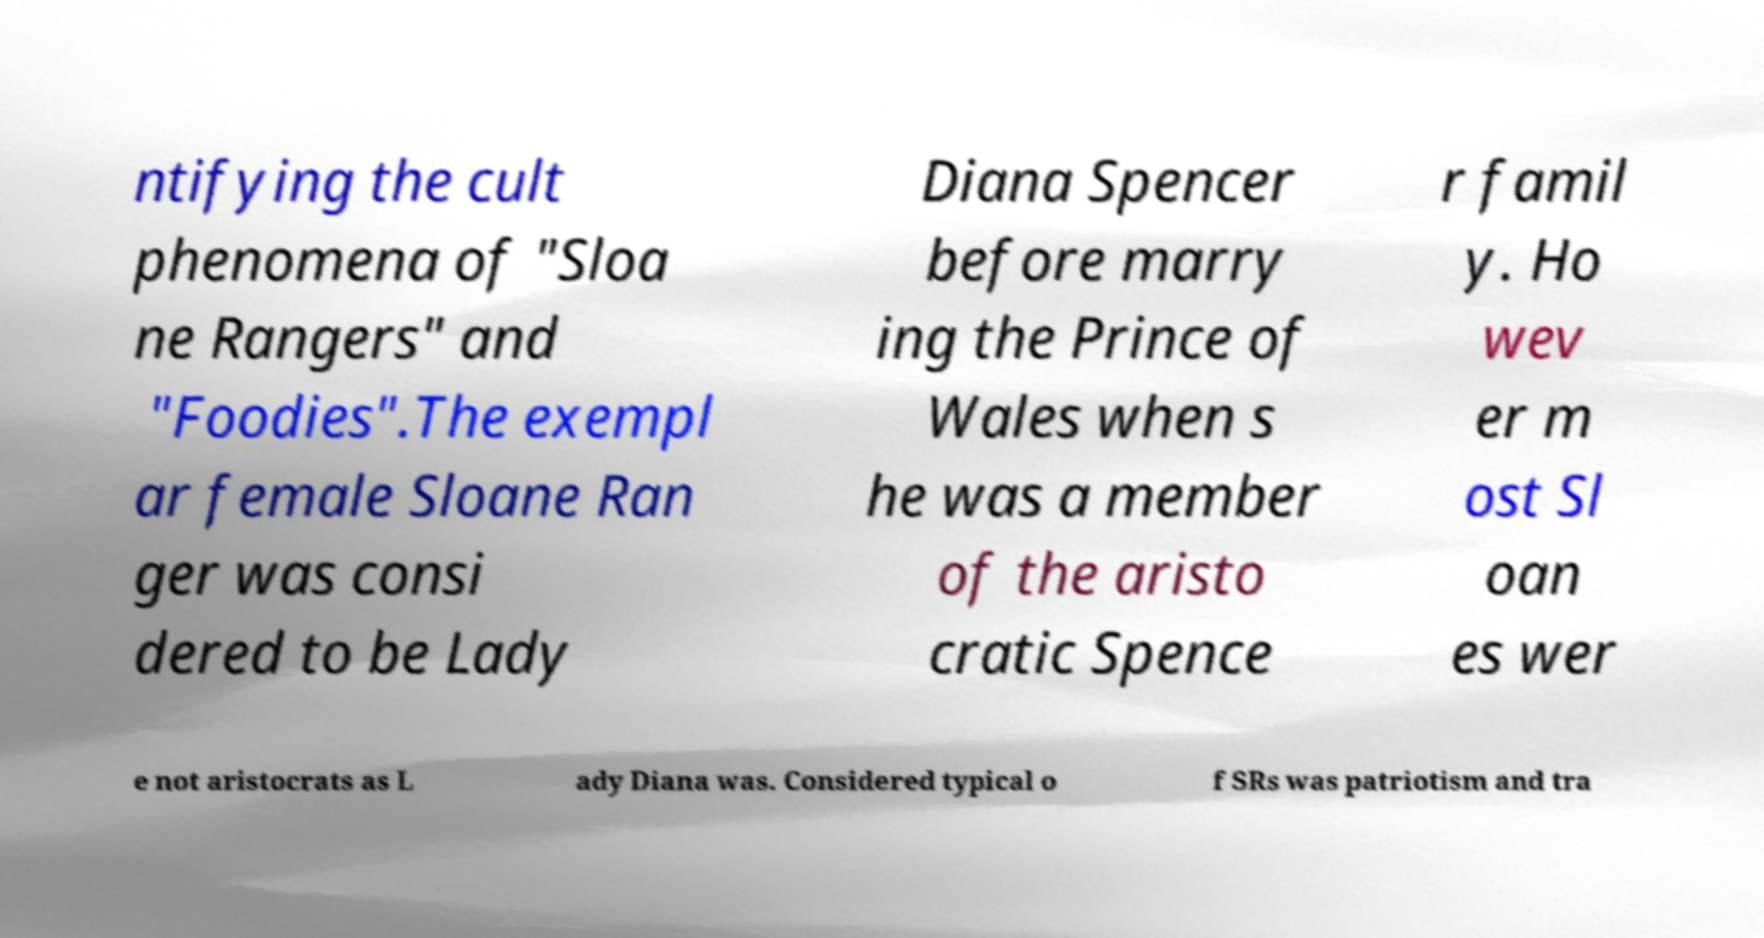I need the written content from this picture converted into text. Can you do that? ntifying the cult phenomena of "Sloa ne Rangers" and "Foodies".The exempl ar female Sloane Ran ger was consi dered to be Lady Diana Spencer before marry ing the Prince of Wales when s he was a member of the aristo cratic Spence r famil y. Ho wev er m ost Sl oan es wer e not aristocrats as L ady Diana was. Considered typical o f SRs was patriotism and tra 